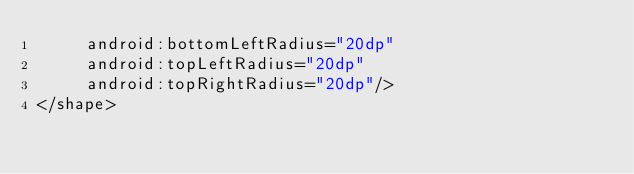<code> <loc_0><loc_0><loc_500><loc_500><_XML_>     android:bottomLeftRadius="20dp"
     android:topLeftRadius="20dp"
     android:topRightRadius="20dp"/>
</shape>

</code> 